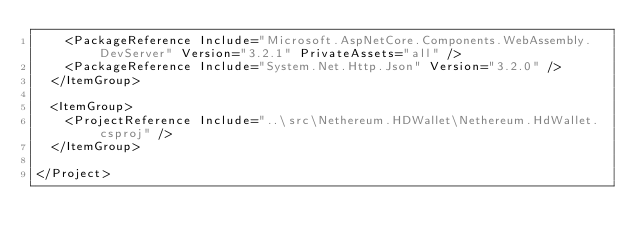Convert code to text. <code><loc_0><loc_0><loc_500><loc_500><_XML_>    <PackageReference Include="Microsoft.AspNetCore.Components.WebAssembly.DevServer" Version="3.2.1" PrivateAssets="all" />
    <PackageReference Include="System.Net.Http.Json" Version="3.2.0" />
  </ItemGroup>

  <ItemGroup>
    <ProjectReference Include="..\src\Nethereum.HDWallet\Nethereum.HdWallet.csproj" />
  </ItemGroup>

</Project>
</code> 